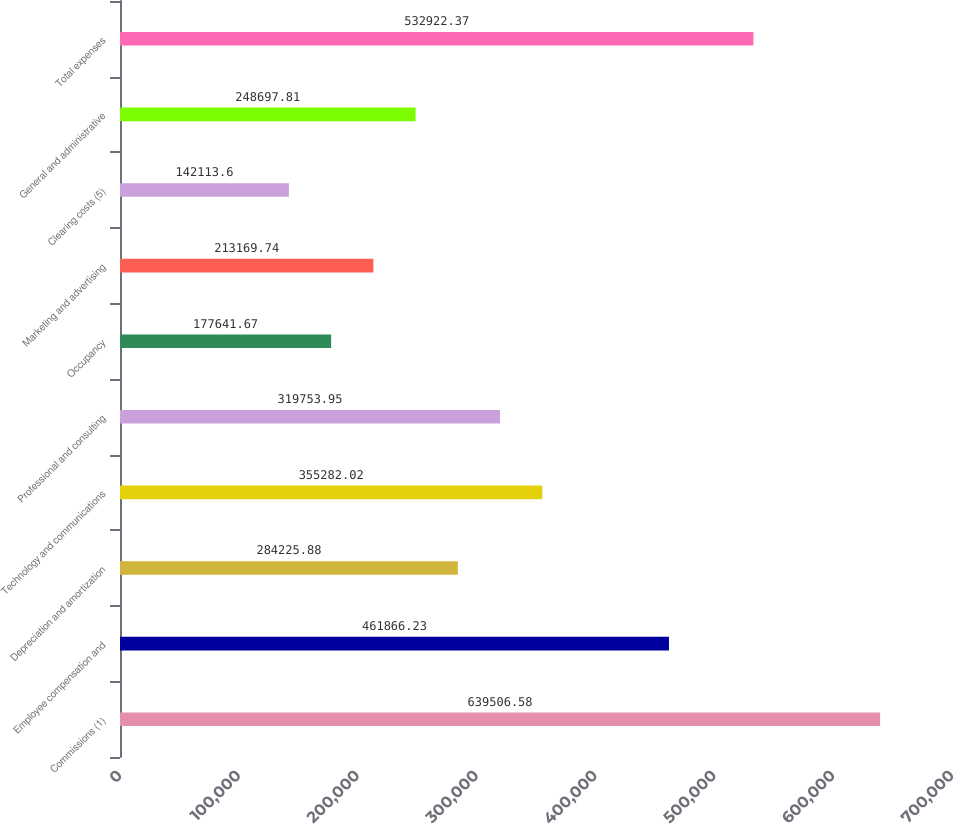Convert chart to OTSL. <chart><loc_0><loc_0><loc_500><loc_500><bar_chart><fcel>Commissions (1)<fcel>Employee compensation and<fcel>Depreciation and amortization<fcel>Technology and communications<fcel>Professional and consulting<fcel>Occupancy<fcel>Marketing and advertising<fcel>Clearing costs (5)<fcel>General and administrative<fcel>Total expenses<nl><fcel>639507<fcel>461866<fcel>284226<fcel>355282<fcel>319754<fcel>177642<fcel>213170<fcel>142114<fcel>248698<fcel>532922<nl></chart> 